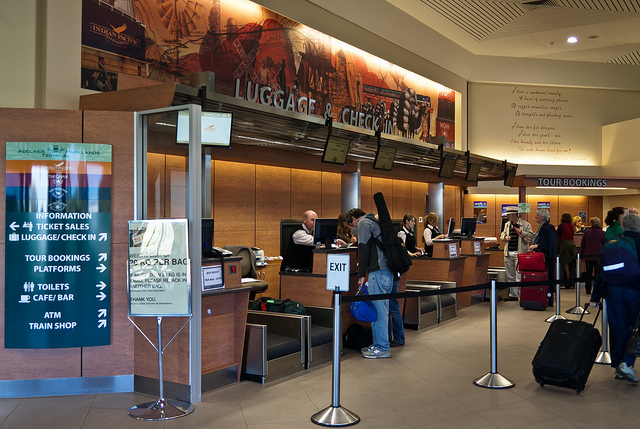How many people are there? There are approximately ten people visible in the image, most of whom appear to be passengers with their luggage, queued at what seems to be a train station ticket counter or luggage check-in area. 